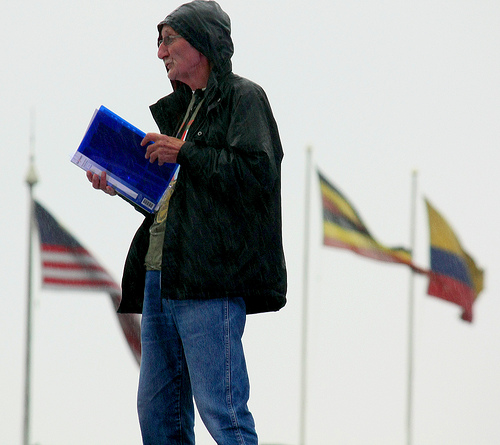<image>
Is the book next to the flag? No. The book is not positioned next to the flag. They are located in different areas of the scene. 